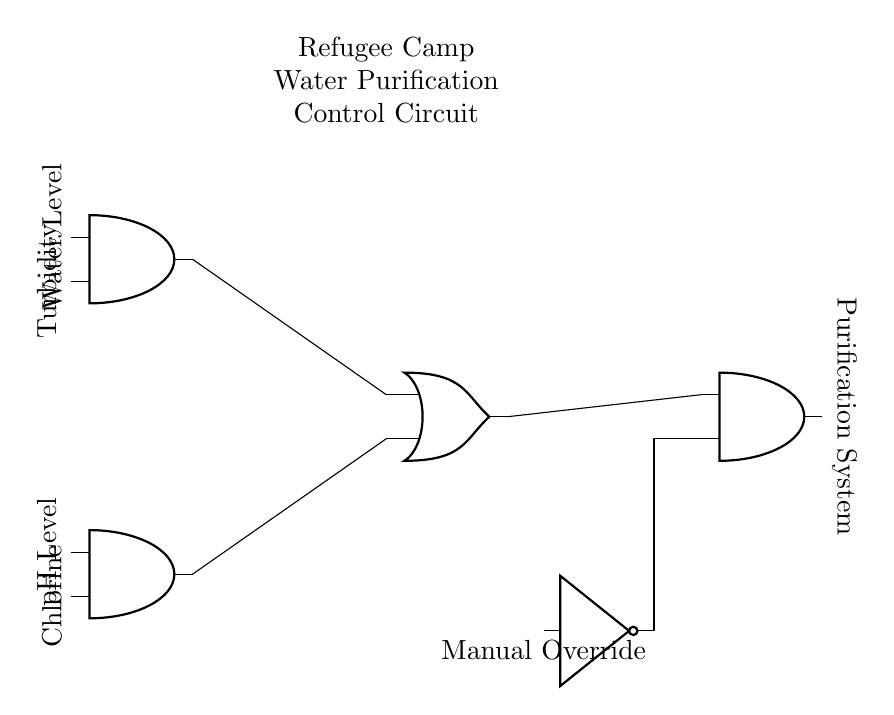What type of logic gate is used to combine water level and turbidity? The circuit uses an AND gate to combine the inputs from the water level and turbidity sensors. In the diagram, the AND gate is clearly labeled as the component connecting these two inputs.
Answer: AND gate What does the output of the OR gate control? The output of the OR gate connects to another AND gate that controls the purification system. Since the OR gate aggregates the outputs from the first two AND gates, it determines when to activate the purification system based on the sensor conditions.
Answer: Purification system How many input conditions are needed to activate the purification system? The purification system can be activated by any combination of inputs from the two AND gates and a manual override. Specifically, at least one of the water level and turbidity AND gate outputs or the manual override must be active for the system to run. Therefore, it requires conditions from the AND gates and possibly from the manual override.
Answer: One condition What components are used to monitor water conditions? The circuit diagram includes two AND gates that take in four specific sensors: water level, turbidity, pH level, and chlorine. Each AND gate processes two of these parameters, directly relating to the assessment of water quality.
Answer: Water level, turbidity, pH level, chlorine How is the manual override integrated into the circuit? The manual override is integrated through a NOT gate, which allows the user to manually control the activation of the purification system regardless of the other sensor inputs. The output of the NOT gate feeds into the second input of the final AND gate for the purification system, making it a safety feature in the design.
Answer: Through a NOT gate 